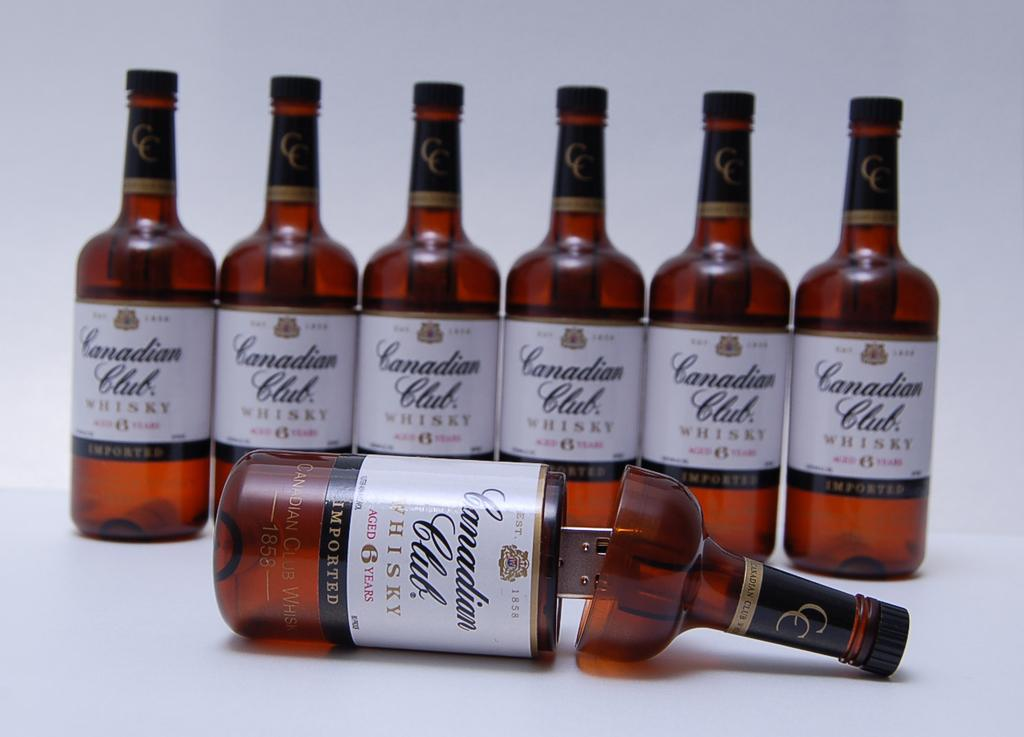<image>
Relay a brief, clear account of the picture shown. Six bottles of Canadian Club are standing up behind a USB drive that looks like a bottle of Canadian Club. 